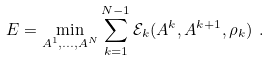Convert formula to latex. <formula><loc_0><loc_0><loc_500><loc_500>E = \min _ { A ^ { 1 } , \dots , A ^ { N } } \sum _ { k = 1 } ^ { N - 1 } \mathcal { E } _ { k } ( A ^ { k } , A ^ { k + 1 } , \rho _ { k } ) \ .</formula> 